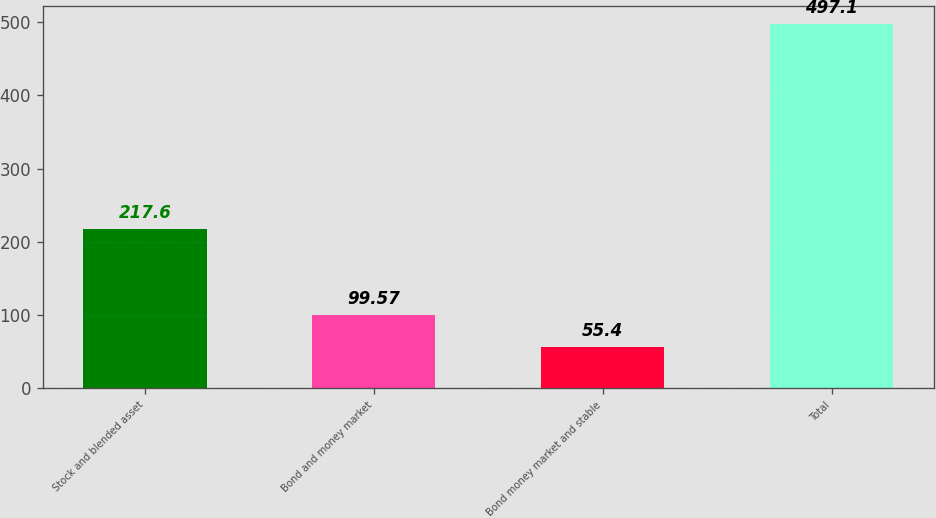Convert chart. <chart><loc_0><loc_0><loc_500><loc_500><bar_chart><fcel>Stock and blended asset<fcel>Bond and money market<fcel>Bond money market and stable<fcel>Total<nl><fcel>217.6<fcel>99.57<fcel>55.4<fcel>497.1<nl></chart> 